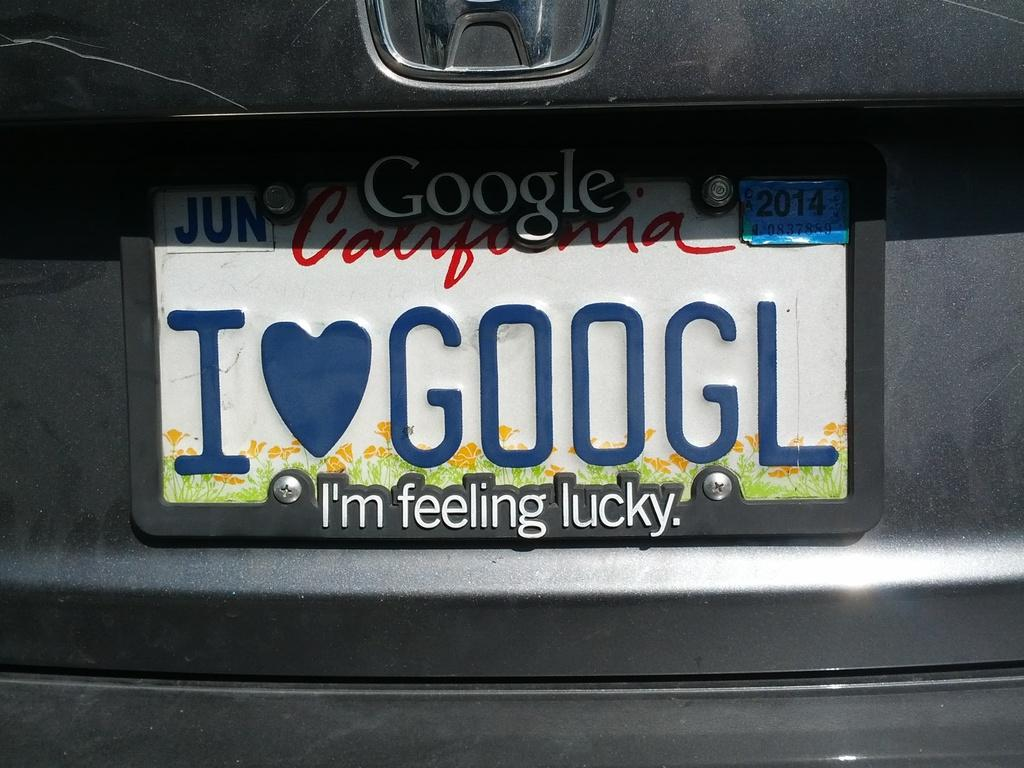<image>
Offer a succinct explanation of the picture presented. The back bumper of a Honda branded vehicle with a California state license plate hanging on it. 